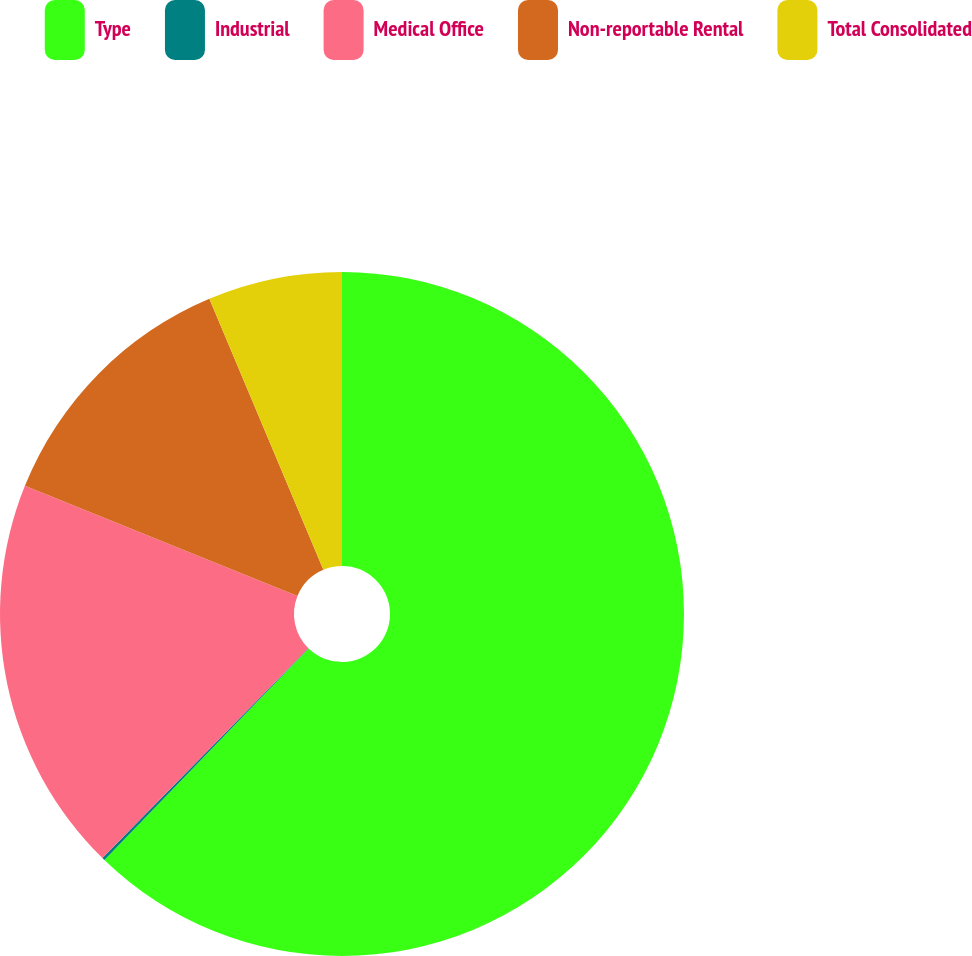Convert chart. <chart><loc_0><loc_0><loc_500><loc_500><pie_chart><fcel>Type<fcel>Industrial<fcel>Medical Office<fcel>Non-reportable Rental<fcel>Total Consolidated<nl><fcel>62.23%<fcel>0.13%<fcel>18.76%<fcel>12.55%<fcel>6.34%<nl></chart> 